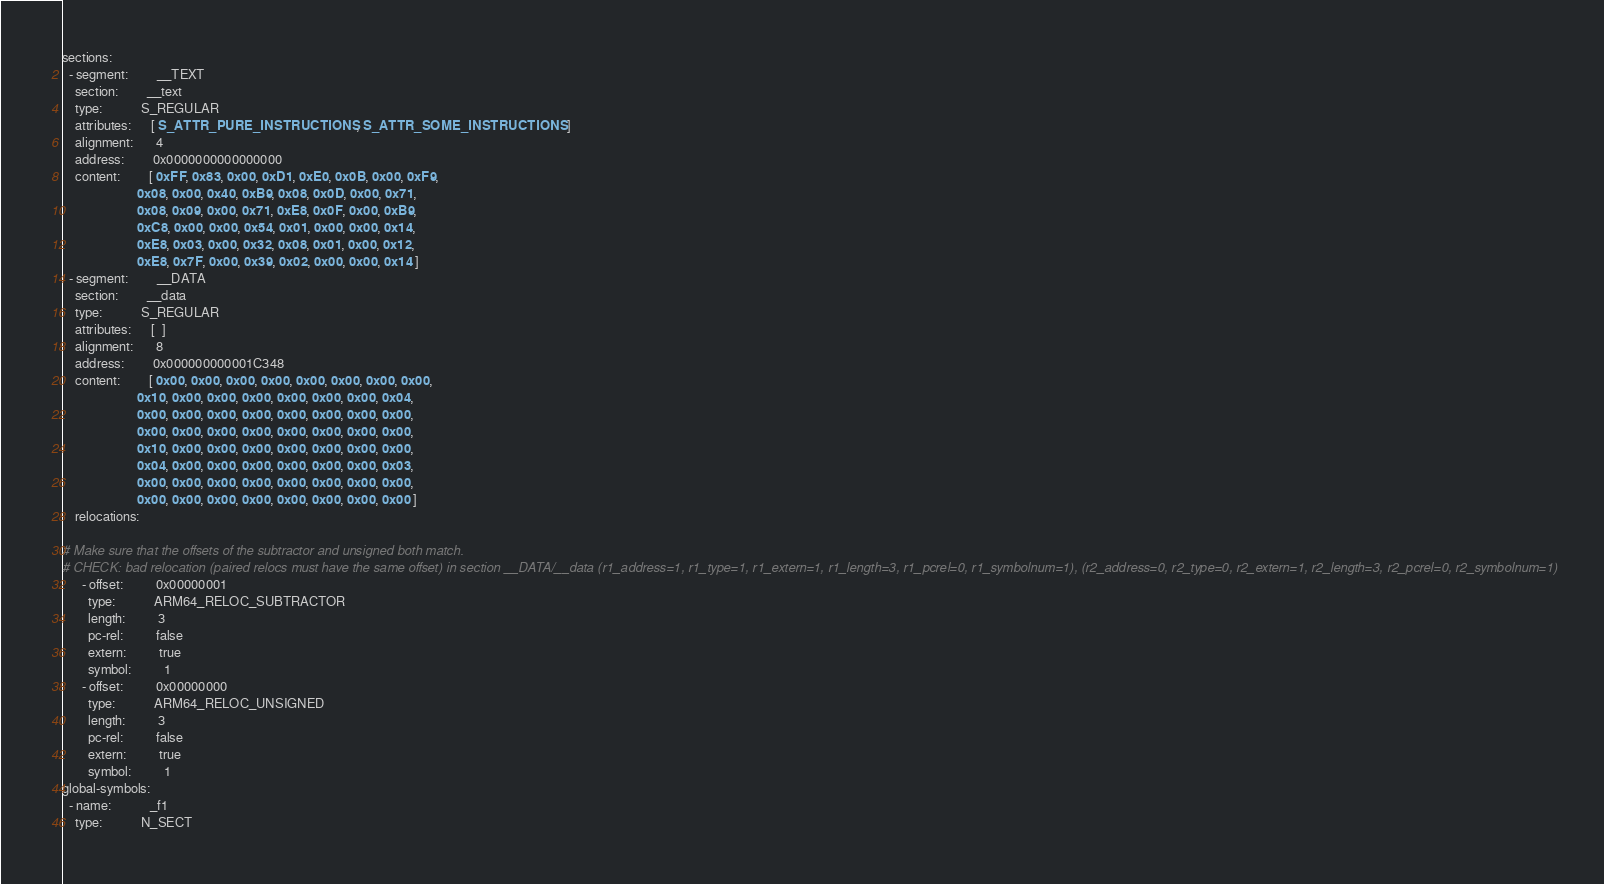Convert code to text. <code><loc_0><loc_0><loc_500><loc_500><_YAML_>sections:
  - segment:         __TEXT
    section:         __text
    type:            S_REGULAR
    attributes:      [ S_ATTR_PURE_INSTRUCTIONS, S_ATTR_SOME_INSTRUCTIONS ]
    alignment:       4
    address:         0x0000000000000000
    content:         [ 0xFF, 0x83, 0x00, 0xD1, 0xE0, 0x0B, 0x00, 0xF9, 
                       0x08, 0x00, 0x40, 0xB9, 0x08, 0x0D, 0x00, 0x71, 
                       0x08, 0x09, 0x00, 0x71, 0xE8, 0x0F, 0x00, 0xB9, 
                       0xC8, 0x00, 0x00, 0x54, 0x01, 0x00, 0x00, 0x14, 
                       0xE8, 0x03, 0x00, 0x32, 0x08, 0x01, 0x00, 0x12, 
                       0xE8, 0x7F, 0x00, 0x39, 0x02, 0x00, 0x00, 0x14 ]
  - segment:         __DATA
    section:         __data
    type:            S_REGULAR
    attributes:      [  ]
    alignment:       8
    address:         0x000000000001C348
    content:         [ 0x00, 0x00, 0x00, 0x00, 0x00, 0x00, 0x00, 0x00,
                       0x10, 0x00, 0x00, 0x00, 0x00, 0x00, 0x00, 0x04,
                       0x00, 0x00, 0x00, 0x00, 0x00, 0x00, 0x00, 0x00,
                       0x00, 0x00, 0x00, 0x00, 0x00, 0x00, 0x00, 0x00,
                       0x10, 0x00, 0x00, 0x00, 0x00, 0x00, 0x00, 0x00,
                       0x04, 0x00, 0x00, 0x00, 0x00, 0x00, 0x00, 0x03,
                       0x00, 0x00, 0x00, 0x00, 0x00, 0x00, 0x00, 0x00,
                       0x00, 0x00, 0x00, 0x00, 0x00, 0x00, 0x00, 0x00 ]
    relocations:     

# Make sure that the offsets of the subtractor and unsigned both match.
# CHECK: bad relocation (paired relocs must have the same offset) in section __DATA/__data (r1_address=1, r1_type=1, r1_extern=1, r1_length=3, r1_pcrel=0, r1_symbolnum=1), (r2_address=0, r2_type=0, r2_extern=1, r2_length=3, r2_pcrel=0, r2_symbolnum=1)
      - offset:          0x00000001
        type:            ARM64_RELOC_SUBTRACTOR
        length:          3
        pc-rel:          false
        extern:          true
        symbol:          1
      - offset:          0x00000000
        type:            ARM64_RELOC_UNSIGNED
        length:          3
        pc-rel:          false
        extern:          true
        symbol:          1
global-symbols:
  - name:            _f1
    type:            N_SECT</code> 